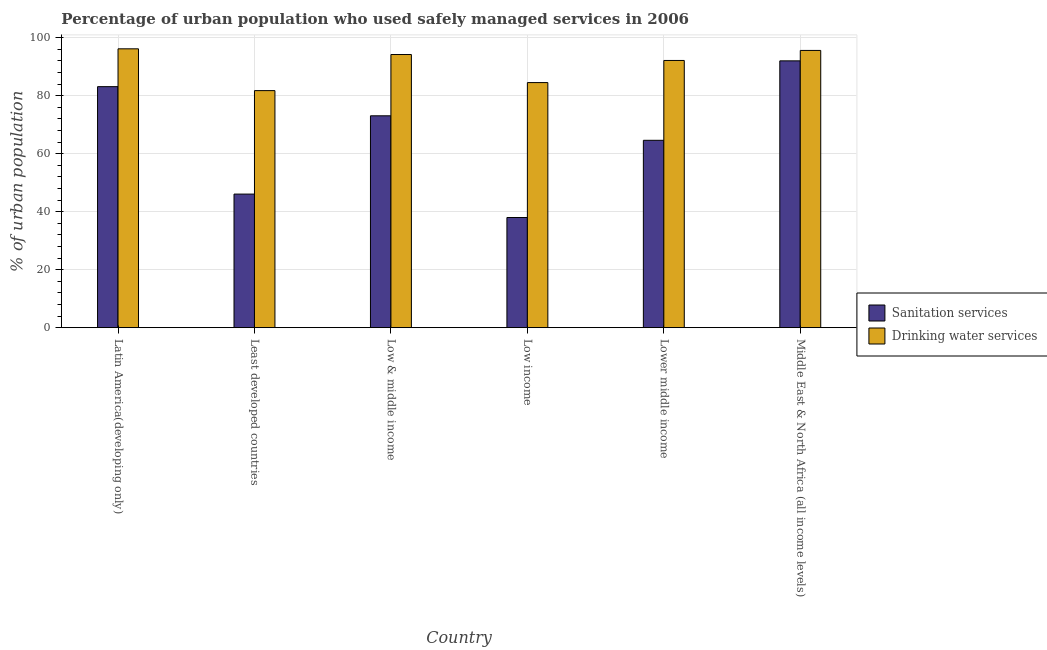How many bars are there on the 1st tick from the left?
Your answer should be compact. 2. How many bars are there on the 5th tick from the right?
Your response must be concise. 2. What is the label of the 4th group of bars from the left?
Your response must be concise. Low income. In how many cases, is the number of bars for a given country not equal to the number of legend labels?
Provide a succinct answer. 0. What is the percentage of urban population who used sanitation services in Low income?
Make the answer very short. 38. Across all countries, what is the maximum percentage of urban population who used drinking water services?
Give a very brief answer. 96.2. Across all countries, what is the minimum percentage of urban population who used sanitation services?
Make the answer very short. 38. In which country was the percentage of urban population who used sanitation services maximum?
Ensure brevity in your answer.  Middle East & North Africa (all income levels). In which country was the percentage of urban population who used drinking water services minimum?
Give a very brief answer. Least developed countries. What is the total percentage of urban population who used drinking water services in the graph?
Your response must be concise. 544.6. What is the difference between the percentage of urban population who used drinking water services in Least developed countries and that in Low & middle income?
Offer a terse response. -12.45. What is the difference between the percentage of urban population who used sanitation services in Low & middle income and the percentage of urban population who used drinking water services in Least developed countries?
Ensure brevity in your answer.  -8.68. What is the average percentage of urban population who used drinking water services per country?
Offer a very short reply. 90.77. What is the difference between the percentage of urban population who used drinking water services and percentage of urban population who used sanitation services in Least developed countries?
Your response must be concise. 35.69. What is the ratio of the percentage of urban population who used sanitation services in Least developed countries to that in Lower middle income?
Provide a succinct answer. 0.71. Is the difference between the percentage of urban population who used drinking water services in Low & middle income and Low income greater than the difference between the percentage of urban population who used sanitation services in Low & middle income and Low income?
Give a very brief answer. No. What is the difference between the highest and the second highest percentage of urban population who used drinking water services?
Keep it short and to the point. 0.56. What is the difference between the highest and the lowest percentage of urban population who used sanitation services?
Offer a very short reply. 54.05. Is the sum of the percentage of urban population who used drinking water services in Least developed countries and Low income greater than the maximum percentage of urban population who used sanitation services across all countries?
Offer a terse response. Yes. What does the 2nd bar from the left in Low income represents?
Offer a very short reply. Drinking water services. What does the 1st bar from the right in Lower middle income represents?
Keep it short and to the point. Drinking water services. Are all the bars in the graph horizontal?
Provide a succinct answer. No. How many countries are there in the graph?
Offer a terse response. 6. What is the difference between two consecutive major ticks on the Y-axis?
Ensure brevity in your answer.  20. Are the values on the major ticks of Y-axis written in scientific E-notation?
Give a very brief answer. No. Does the graph contain any zero values?
Your answer should be very brief. No. Does the graph contain grids?
Make the answer very short. Yes. How are the legend labels stacked?
Offer a terse response. Vertical. What is the title of the graph?
Your response must be concise. Percentage of urban population who used safely managed services in 2006. Does "GDP per capita" appear as one of the legend labels in the graph?
Keep it short and to the point. No. What is the label or title of the Y-axis?
Your answer should be very brief. % of urban population. What is the % of urban population in Sanitation services in Latin America(developing only)?
Keep it short and to the point. 83.15. What is the % of urban population of Drinking water services in Latin America(developing only)?
Offer a very short reply. 96.2. What is the % of urban population in Sanitation services in Least developed countries?
Provide a succinct answer. 46.09. What is the % of urban population of Drinking water services in Least developed countries?
Offer a terse response. 81.78. What is the % of urban population of Sanitation services in Low & middle income?
Offer a terse response. 73.09. What is the % of urban population of Drinking water services in Low & middle income?
Make the answer very short. 94.23. What is the % of urban population of Sanitation services in Low income?
Make the answer very short. 38. What is the % of urban population of Drinking water services in Low income?
Make the answer very short. 84.55. What is the % of urban population in Sanitation services in Lower middle income?
Your response must be concise. 64.64. What is the % of urban population in Drinking water services in Lower middle income?
Provide a succinct answer. 92.18. What is the % of urban population of Sanitation services in Middle East & North Africa (all income levels)?
Offer a terse response. 92.05. What is the % of urban population in Drinking water services in Middle East & North Africa (all income levels)?
Offer a very short reply. 95.65. Across all countries, what is the maximum % of urban population in Sanitation services?
Provide a short and direct response. 92.05. Across all countries, what is the maximum % of urban population of Drinking water services?
Keep it short and to the point. 96.2. Across all countries, what is the minimum % of urban population of Sanitation services?
Offer a terse response. 38. Across all countries, what is the minimum % of urban population of Drinking water services?
Your response must be concise. 81.78. What is the total % of urban population in Sanitation services in the graph?
Keep it short and to the point. 397.02. What is the total % of urban population in Drinking water services in the graph?
Give a very brief answer. 544.6. What is the difference between the % of urban population in Sanitation services in Latin America(developing only) and that in Least developed countries?
Offer a terse response. 37.06. What is the difference between the % of urban population of Drinking water services in Latin America(developing only) and that in Least developed countries?
Your response must be concise. 14.42. What is the difference between the % of urban population in Sanitation services in Latin America(developing only) and that in Low & middle income?
Ensure brevity in your answer.  10.06. What is the difference between the % of urban population of Drinking water services in Latin America(developing only) and that in Low & middle income?
Give a very brief answer. 1.97. What is the difference between the % of urban population of Sanitation services in Latin America(developing only) and that in Low income?
Provide a short and direct response. 45.15. What is the difference between the % of urban population in Drinking water services in Latin America(developing only) and that in Low income?
Your answer should be compact. 11.65. What is the difference between the % of urban population of Sanitation services in Latin America(developing only) and that in Lower middle income?
Provide a short and direct response. 18.51. What is the difference between the % of urban population of Drinking water services in Latin America(developing only) and that in Lower middle income?
Give a very brief answer. 4.02. What is the difference between the % of urban population in Sanitation services in Latin America(developing only) and that in Middle East & North Africa (all income levels)?
Provide a succinct answer. -8.9. What is the difference between the % of urban population of Drinking water services in Latin America(developing only) and that in Middle East & North Africa (all income levels)?
Your response must be concise. 0.56. What is the difference between the % of urban population in Sanitation services in Least developed countries and that in Low & middle income?
Provide a succinct answer. -27.01. What is the difference between the % of urban population in Drinking water services in Least developed countries and that in Low & middle income?
Give a very brief answer. -12.45. What is the difference between the % of urban population in Sanitation services in Least developed countries and that in Low income?
Your answer should be compact. 8.08. What is the difference between the % of urban population of Drinking water services in Least developed countries and that in Low income?
Offer a very short reply. -2.77. What is the difference between the % of urban population in Sanitation services in Least developed countries and that in Lower middle income?
Keep it short and to the point. -18.55. What is the difference between the % of urban population in Drinking water services in Least developed countries and that in Lower middle income?
Offer a terse response. -10.41. What is the difference between the % of urban population of Sanitation services in Least developed countries and that in Middle East & North Africa (all income levels)?
Your answer should be compact. -45.96. What is the difference between the % of urban population in Drinking water services in Least developed countries and that in Middle East & North Africa (all income levels)?
Offer a very short reply. -13.87. What is the difference between the % of urban population of Sanitation services in Low & middle income and that in Low income?
Make the answer very short. 35.09. What is the difference between the % of urban population in Drinking water services in Low & middle income and that in Low income?
Offer a terse response. 9.68. What is the difference between the % of urban population of Sanitation services in Low & middle income and that in Lower middle income?
Offer a terse response. 8.46. What is the difference between the % of urban population in Drinking water services in Low & middle income and that in Lower middle income?
Ensure brevity in your answer.  2.05. What is the difference between the % of urban population of Sanitation services in Low & middle income and that in Middle East & North Africa (all income levels)?
Offer a terse response. -18.95. What is the difference between the % of urban population of Drinking water services in Low & middle income and that in Middle East & North Africa (all income levels)?
Give a very brief answer. -1.41. What is the difference between the % of urban population in Sanitation services in Low income and that in Lower middle income?
Your response must be concise. -26.64. What is the difference between the % of urban population of Drinking water services in Low income and that in Lower middle income?
Your answer should be very brief. -7.63. What is the difference between the % of urban population of Sanitation services in Low income and that in Middle East & North Africa (all income levels)?
Provide a succinct answer. -54.05. What is the difference between the % of urban population of Drinking water services in Low income and that in Middle East & North Africa (all income levels)?
Keep it short and to the point. -11.1. What is the difference between the % of urban population of Sanitation services in Lower middle income and that in Middle East & North Africa (all income levels)?
Offer a terse response. -27.41. What is the difference between the % of urban population of Drinking water services in Lower middle income and that in Middle East & North Africa (all income levels)?
Make the answer very short. -3.46. What is the difference between the % of urban population of Sanitation services in Latin America(developing only) and the % of urban population of Drinking water services in Least developed countries?
Provide a short and direct response. 1.37. What is the difference between the % of urban population of Sanitation services in Latin America(developing only) and the % of urban population of Drinking water services in Low & middle income?
Your answer should be compact. -11.08. What is the difference between the % of urban population of Sanitation services in Latin America(developing only) and the % of urban population of Drinking water services in Low income?
Provide a succinct answer. -1.4. What is the difference between the % of urban population of Sanitation services in Latin America(developing only) and the % of urban population of Drinking water services in Lower middle income?
Offer a terse response. -9.03. What is the difference between the % of urban population of Sanitation services in Latin America(developing only) and the % of urban population of Drinking water services in Middle East & North Africa (all income levels)?
Ensure brevity in your answer.  -12.5. What is the difference between the % of urban population in Sanitation services in Least developed countries and the % of urban population in Drinking water services in Low & middle income?
Provide a short and direct response. -48.15. What is the difference between the % of urban population in Sanitation services in Least developed countries and the % of urban population in Drinking water services in Low income?
Ensure brevity in your answer.  -38.46. What is the difference between the % of urban population of Sanitation services in Least developed countries and the % of urban population of Drinking water services in Lower middle income?
Your response must be concise. -46.1. What is the difference between the % of urban population of Sanitation services in Least developed countries and the % of urban population of Drinking water services in Middle East & North Africa (all income levels)?
Ensure brevity in your answer.  -49.56. What is the difference between the % of urban population in Sanitation services in Low & middle income and the % of urban population in Drinking water services in Low income?
Keep it short and to the point. -11.46. What is the difference between the % of urban population of Sanitation services in Low & middle income and the % of urban population of Drinking water services in Lower middle income?
Keep it short and to the point. -19.09. What is the difference between the % of urban population of Sanitation services in Low & middle income and the % of urban population of Drinking water services in Middle East & North Africa (all income levels)?
Keep it short and to the point. -22.55. What is the difference between the % of urban population of Sanitation services in Low income and the % of urban population of Drinking water services in Lower middle income?
Ensure brevity in your answer.  -54.18. What is the difference between the % of urban population of Sanitation services in Low income and the % of urban population of Drinking water services in Middle East & North Africa (all income levels)?
Make the answer very short. -57.65. What is the difference between the % of urban population of Sanitation services in Lower middle income and the % of urban population of Drinking water services in Middle East & North Africa (all income levels)?
Keep it short and to the point. -31.01. What is the average % of urban population of Sanitation services per country?
Your answer should be very brief. 66.17. What is the average % of urban population in Drinking water services per country?
Your response must be concise. 90.77. What is the difference between the % of urban population in Sanitation services and % of urban population in Drinking water services in Latin America(developing only)?
Provide a succinct answer. -13.05. What is the difference between the % of urban population in Sanitation services and % of urban population in Drinking water services in Least developed countries?
Your answer should be very brief. -35.69. What is the difference between the % of urban population of Sanitation services and % of urban population of Drinking water services in Low & middle income?
Make the answer very short. -21.14. What is the difference between the % of urban population of Sanitation services and % of urban population of Drinking water services in Low income?
Your response must be concise. -46.55. What is the difference between the % of urban population of Sanitation services and % of urban population of Drinking water services in Lower middle income?
Provide a short and direct response. -27.55. What is the difference between the % of urban population in Sanitation services and % of urban population in Drinking water services in Middle East & North Africa (all income levels)?
Your answer should be very brief. -3.6. What is the ratio of the % of urban population in Sanitation services in Latin America(developing only) to that in Least developed countries?
Your answer should be very brief. 1.8. What is the ratio of the % of urban population in Drinking water services in Latin America(developing only) to that in Least developed countries?
Your answer should be compact. 1.18. What is the ratio of the % of urban population in Sanitation services in Latin America(developing only) to that in Low & middle income?
Offer a terse response. 1.14. What is the ratio of the % of urban population of Drinking water services in Latin America(developing only) to that in Low & middle income?
Keep it short and to the point. 1.02. What is the ratio of the % of urban population of Sanitation services in Latin America(developing only) to that in Low income?
Provide a short and direct response. 2.19. What is the ratio of the % of urban population in Drinking water services in Latin America(developing only) to that in Low income?
Give a very brief answer. 1.14. What is the ratio of the % of urban population of Sanitation services in Latin America(developing only) to that in Lower middle income?
Provide a short and direct response. 1.29. What is the ratio of the % of urban population in Drinking water services in Latin America(developing only) to that in Lower middle income?
Your answer should be very brief. 1.04. What is the ratio of the % of urban population of Sanitation services in Latin America(developing only) to that in Middle East & North Africa (all income levels)?
Provide a short and direct response. 0.9. What is the ratio of the % of urban population in Drinking water services in Latin America(developing only) to that in Middle East & North Africa (all income levels)?
Make the answer very short. 1.01. What is the ratio of the % of urban population in Sanitation services in Least developed countries to that in Low & middle income?
Your answer should be compact. 0.63. What is the ratio of the % of urban population of Drinking water services in Least developed countries to that in Low & middle income?
Make the answer very short. 0.87. What is the ratio of the % of urban population in Sanitation services in Least developed countries to that in Low income?
Provide a succinct answer. 1.21. What is the ratio of the % of urban population in Drinking water services in Least developed countries to that in Low income?
Keep it short and to the point. 0.97. What is the ratio of the % of urban population of Sanitation services in Least developed countries to that in Lower middle income?
Your response must be concise. 0.71. What is the ratio of the % of urban population in Drinking water services in Least developed countries to that in Lower middle income?
Your answer should be very brief. 0.89. What is the ratio of the % of urban population of Sanitation services in Least developed countries to that in Middle East & North Africa (all income levels)?
Your response must be concise. 0.5. What is the ratio of the % of urban population of Drinking water services in Least developed countries to that in Middle East & North Africa (all income levels)?
Give a very brief answer. 0.85. What is the ratio of the % of urban population in Sanitation services in Low & middle income to that in Low income?
Give a very brief answer. 1.92. What is the ratio of the % of urban population of Drinking water services in Low & middle income to that in Low income?
Ensure brevity in your answer.  1.11. What is the ratio of the % of urban population of Sanitation services in Low & middle income to that in Lower middle income?
Give a very brief answer. 1.13. What is the ratio of the % of urban population in Drinking water services in Low & middle income to that in Lower middle income?
Offer a terse response. 1.02. What is the ratio of the % of urban population of Sanitation services in Low & middle income to that in Middle East & North Africa (all income levels)?
Give a very brief answer. 0.79. What is the ratio of the % of urban population in Drinking water services in Low & middle income to that in Middle East & North Africa (all income levels)?
Ensure brevity in your answer.  0.99. What is the ratio of the % of urban population of Sanitation services in Low income to that in Lower middle income?
Give a very brief answer. 0.59. What is the ratio of the % of urban population of Drinking water services in Low income to that in Lower middle income?
Your response must be concise. 0.92. What is the ratio of the % of urban population of Sanitation services in Low income to that in Middle East & North Africa (all income levels)?
Your answer should be compact. 0.41. What is the ratio of the % of urban population in Drinking water services in Low income to that in Middle East & North Africa (all income levels)?
Offer a terse response. 0.88. What is the ratio of the % of urban population in Sanitation services in Lower middle income to that in Middle East & North Africa (all income levels)?
Give a very brief answer. 0.7. What is the ratio of the % of urban population in Drinking water services in Lower middle income to that in Middle East & North Africa (all income levels)?
Make the answer very short. 0.96. What is the difference between the highest and the second highest % of urban population of Sanitation services?
Ensure brevity in your answer.  8.9. What is the difference between the highest and the second highest % of urban population of Drinking water services?
Make the answer very short. 0.56. What is the difference between the highest and the lowest % of urban population of Sanitation services?
Provide a short and direct response. 54.05. What is the difference between the highest and the lowest % of urban population in Drinking water services?
Make the answer very short. 14.42. 